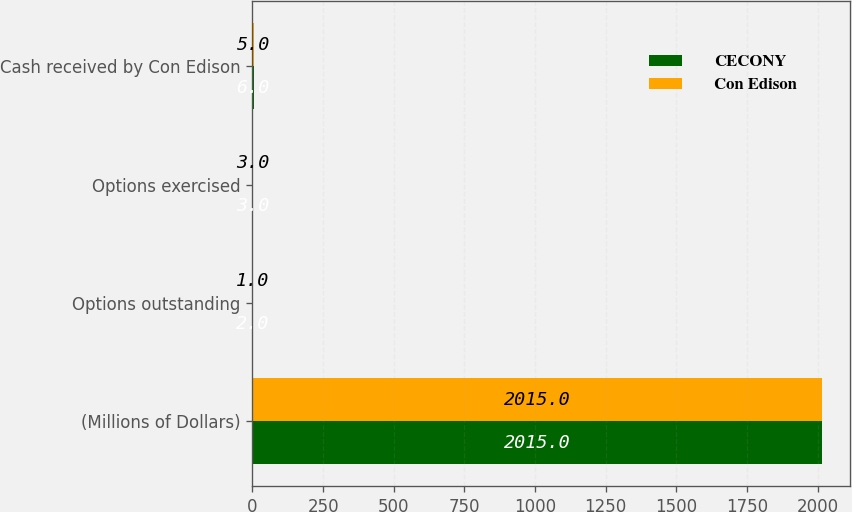Convert chart to OTSL. <chart><loc_0><loc_0><loc_500><loc_500><stacked_bar_chart><ecel><fcel>(Millions of Dollars)<fcel>Options outstanding<fcel>Options exercised<fcel>Cash received by Con Edison<nl><fcel>CECONY<fcel>2015<fcel>2<fcel>3<fcel>6<nl><fcel>Con Edison<fcel>2015<fcel>1<fcel>3<fcel>5<nl></chart> 